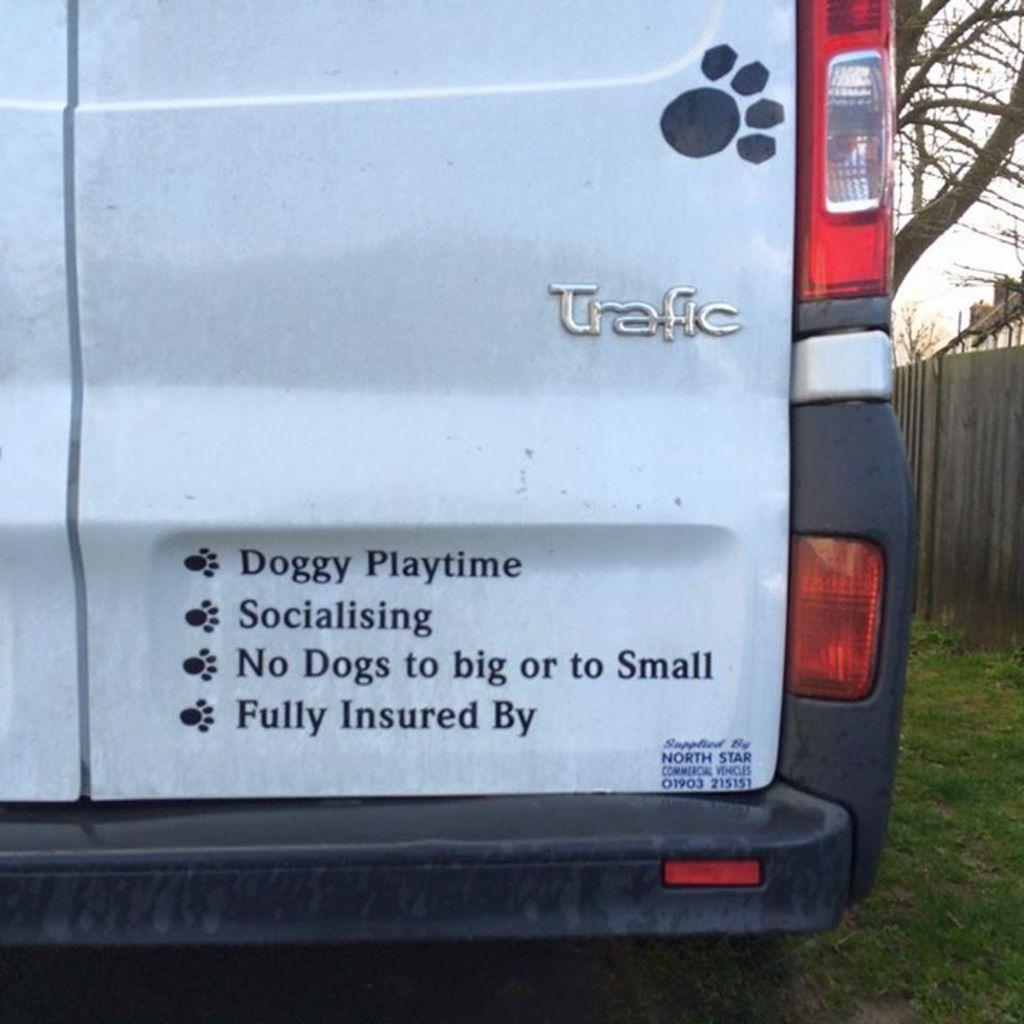Could you give a brief overview of what you see in this image? This is the picture of a vehicle. In this image there is a vehicle and there is a text on the vehicle. On the right side of the image there is a building behind the wooden fence and there is a tree. At the top there is sky. At the bottom there is grass. 